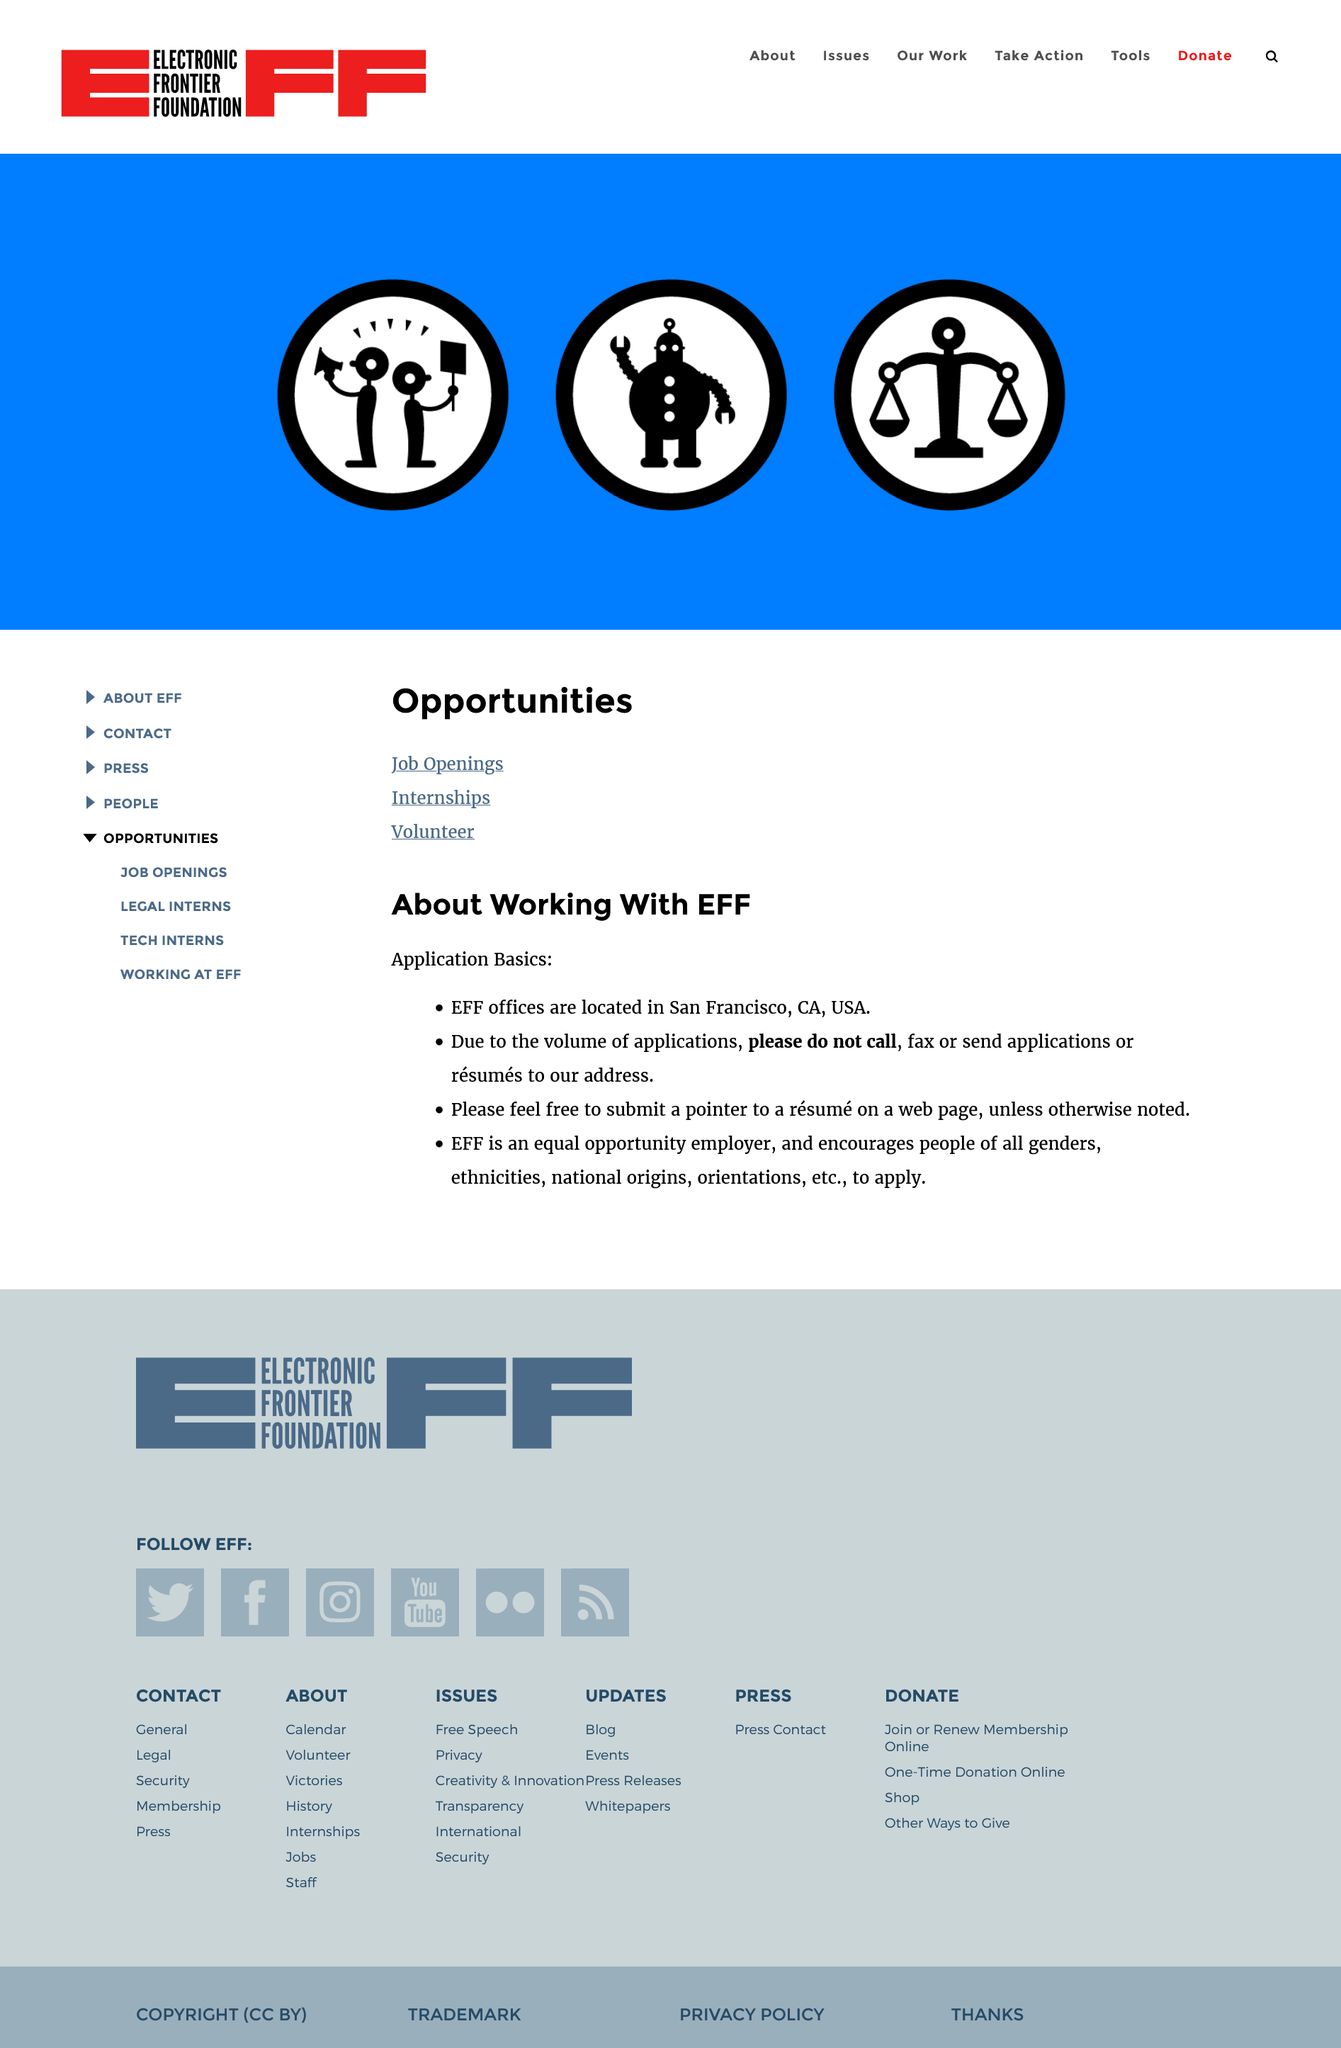Highlight a few significant elements in this photo. The Electronic Frontier Foundation (EFF) has offices in San Francisco, California, in the United States. It is feasible for women to work with the EFF, as the organization is an equal opportunity employer and values diversity, including gender, ethnicity, national origin, orientation, etc. EFF offers various opportunities for individuals to get involved, including job openings, internships, and volunteer positions. 